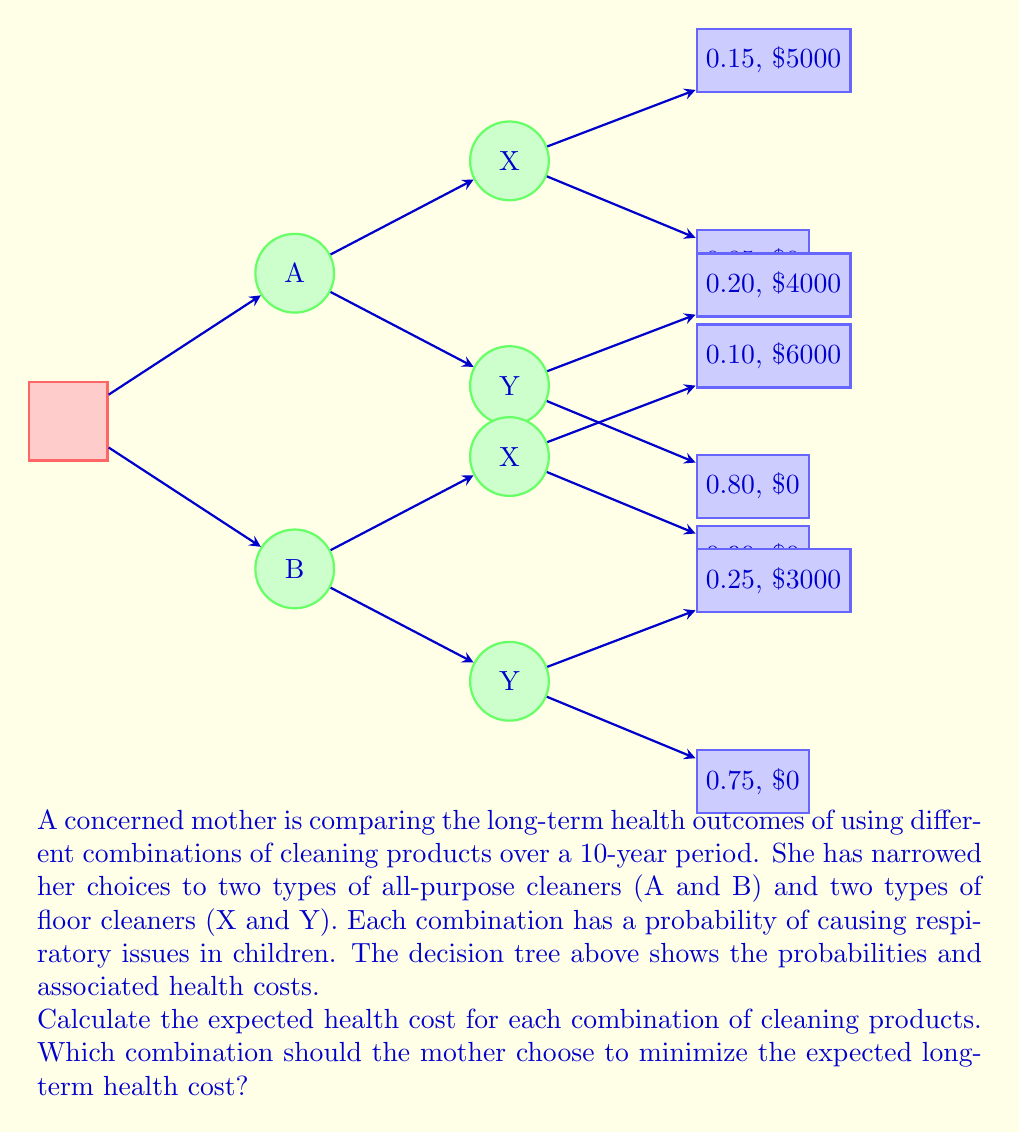Help me with this question. Let's calculate the expected health cost for each combination:

1. Combination A-X:
   $$E(A-X) = 0.15 \times \$5000 + 0.85 \times \$0 = \$750$$

2. Combination A-Y:
   $$E(A-Y) = 0.20 \times \$4000 + 0.80 \times \$0 = \$800$$

3. Combination B-X:
   $$E(B-X) = 0.10 \times \$6000 + 0.90 \times \$0 = \$600$$

4. Combination B-Y:
   $$E(B-Y) = 0.25 \times \$3000 + 0.75 \times \$0 = \$750$$

To minimize the expected long-term health cost, we need to choose the combination with the lowest expected value. Comparing the results:

$$E(B-X) < E(A-X) = E(B-Y) < E(A-Y)$$

Therefore, the combination B-X (all-purpose cleaner B and floor cleaner X) has the lowest expected health cost of $600.
Answer: Combination B-X (expected cost: $600) 